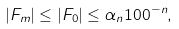<formula> <loc_0><loc_0><loc_500><loc_500>| F _ { m } | \leq | F _ { 0 } | \leq \alpha _ { n } 1 0 0 ^ { - n } ,</formula> 